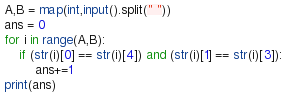<code> <loc_0><loc_0><loc_500><loc_500><_Python_>A,B = map(int,input().split(" "))
ans = 0
for i in range(A,B):
    if (str(i)[0] == str(i)[4]) and (str(i)[1] == str(i)[3]):
        ans+=1
print(ans)</code> 